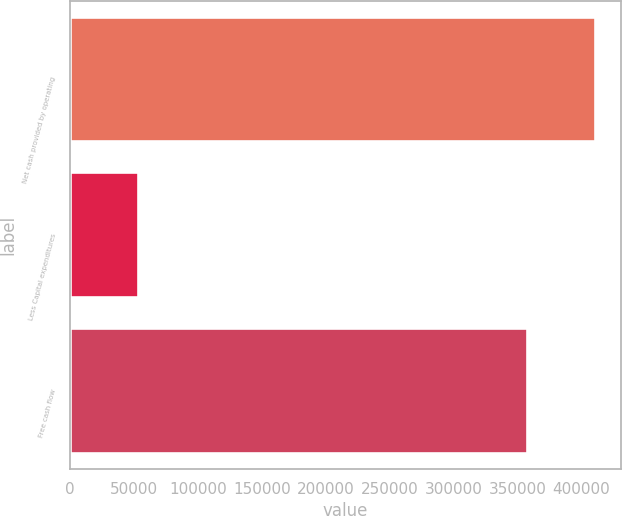<chart> <loc_0><loc_0><loc_500><loc_500><bar_chart><fcel>Net cash provided by operating<fcel>Less Capital expenditures<fcel>Free cash flow<nl><fcel>410590<fcel>53135<fcel>357455<nl></chart> 